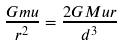Convert formula to latex. <formula><loc_0><loc_0><loc_500><loc_500>\frac { G m u } { r ^ { 2 } } = \frac { 2 G M u r } { d ^ { 3 } }</formula> 